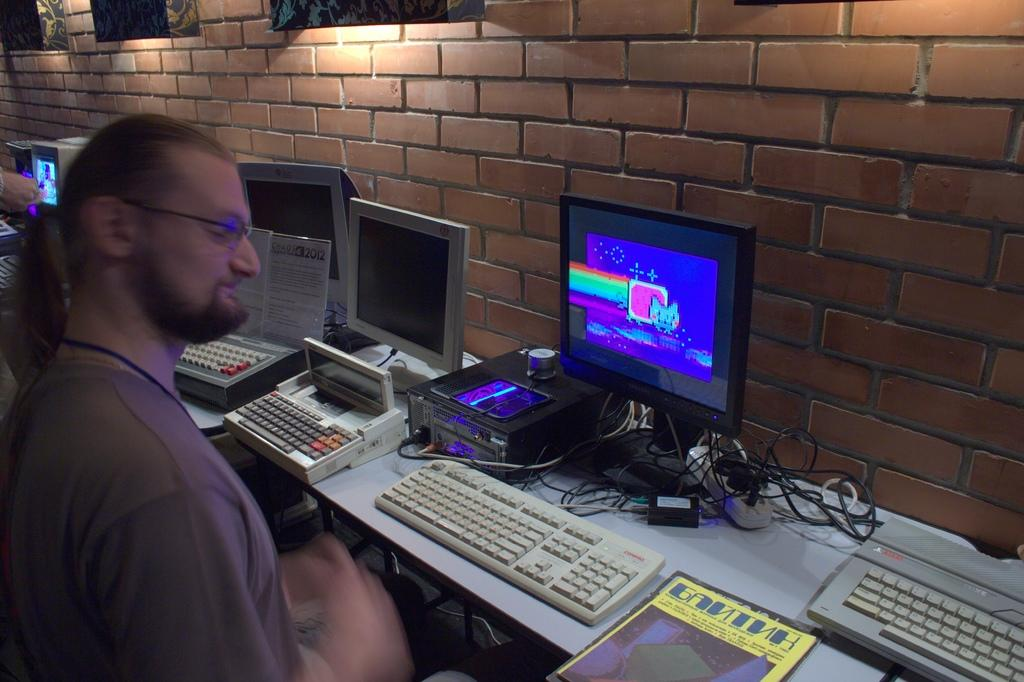What is the man in the image doing? There is a man sitting in the image. What type of equipment is visible in the image? There are monitors and keyboards in the image. What connects the equipment in the image? There are cables in the image. Where are the objects located in the image? There are objects on tables and on the wall in the image. What hobbies does the sheep in the image enjoy? There is no sheep present in the image; it only features a man sitting and various equipment and objects. 